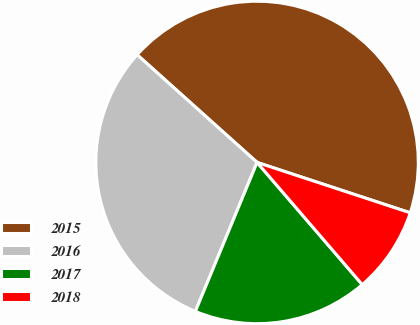Convert chart to OTSL. <chart><loc_0><loc_0><loc_500><loc_500><pie_chart><fcel>2015<fcel>2016<fcel>2017<fcel>2018<nl><fcel>43.42%<fcel>30.39%<fcel>17.56%<fcel>8.63%<nl></chart> 